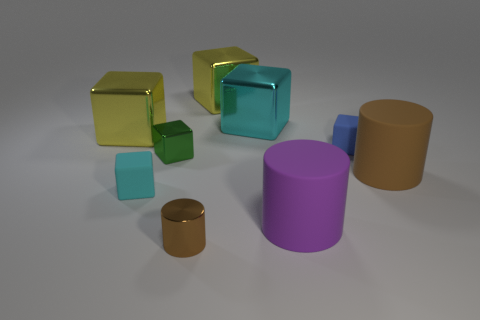How many cyan blocks must be subtracted to get 1 cyan blocks? 1 Subtract all gray blocks. How many brown cylinders are left? 2 Subtract all yellow cubes. How many cubes are left? 4 Subtract 1 blocks. How many blocks are left? 5 Subtract all blue matte cubes. How many cubes are left? 5 Subtract all cylinders. How many objects are left? 6 Subtract all yellow blocks. Subtract all brown balls. How many blocks are left? 4 Subtract all red matte objects. Subtract all cyan metallic things. How many objects are left? 8 Add 8 small blue rubber blocks. How many small blue rubber blocks are left? 9 Add 3 big red matte cylinders. How many big red matte cylinders exist? 3 